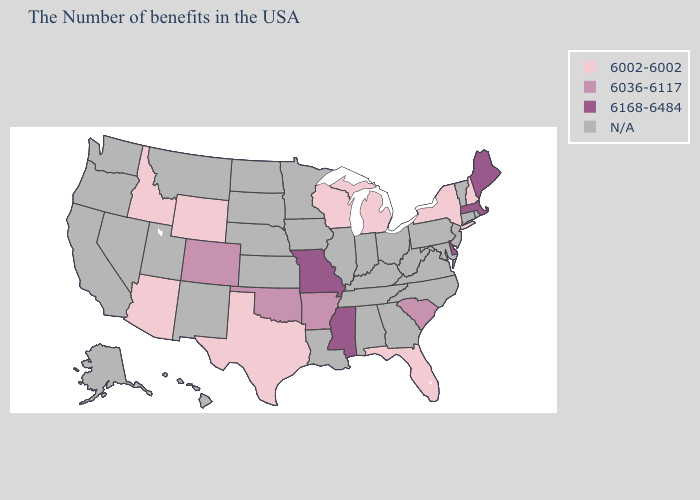Does Missouri have the lowest value in the USA?
Short answer required. No. Name the states that have a value in the range 6168-6484?
Be succinct. Maine, Massachusetts, Delaware, Mississippi, Missouri. What is the value of Minnesota?
Quick response, please. N/A. What is the value of Idaho?
Answer briefly. 6002-6002. Does Colorado have the highest value in the USA?
Give a very brief answer. No. What is the value of Minnesota?
Give a very brief answer. N/A. What is the value of Louisiana?
Concise answer only. N/A. Name the states that have a value in the range N/A?
Answer briefly. Rhode Island, Vermont, Connecticut, New Jersey, Maryland, Pennsylvania, Virginia, North Carolina, West Virginia, Ohio, Georgia, Kentucky, Indiana, Alabama, Tennessee, Illinois, Louisiana, Minnesota, Iowa, Kansas, Nebraska, South Dakota, North Dakota, New Mexico, Utah, Montana, Nevada, California, Washington, Oregon, Alaska, Hawaii. Which states have the lowest value in the USA?
Concise answer only. New Hampshire, New York, Florida, Michigan, Wisconsin, Texas, Wyoming, Arizona, Idaho. What is the value of Florida?
Write a very short answer. 6002-6002. What is the value of Pennsylvania?
Keep it brief. N/A. Does South Carolina have the highest value in the USA?
Short answer required. No. Is the legend a continuous bar?
Be succinct. No. What is the value of Ohio?
Concise answer only. N/A. What is the value of Minnesota?
Short answer required. N/A. 